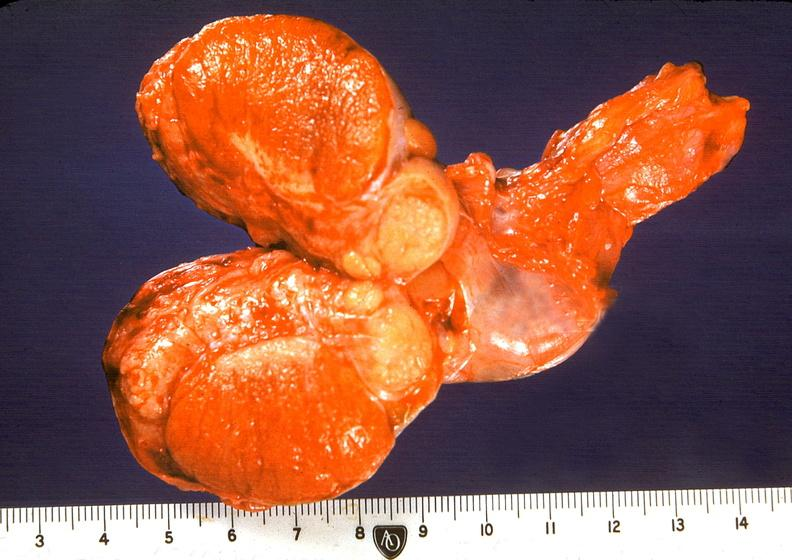does this image show orchitis and epididymitis, subacute?
Answer the question using a single word or phrase. Yes 